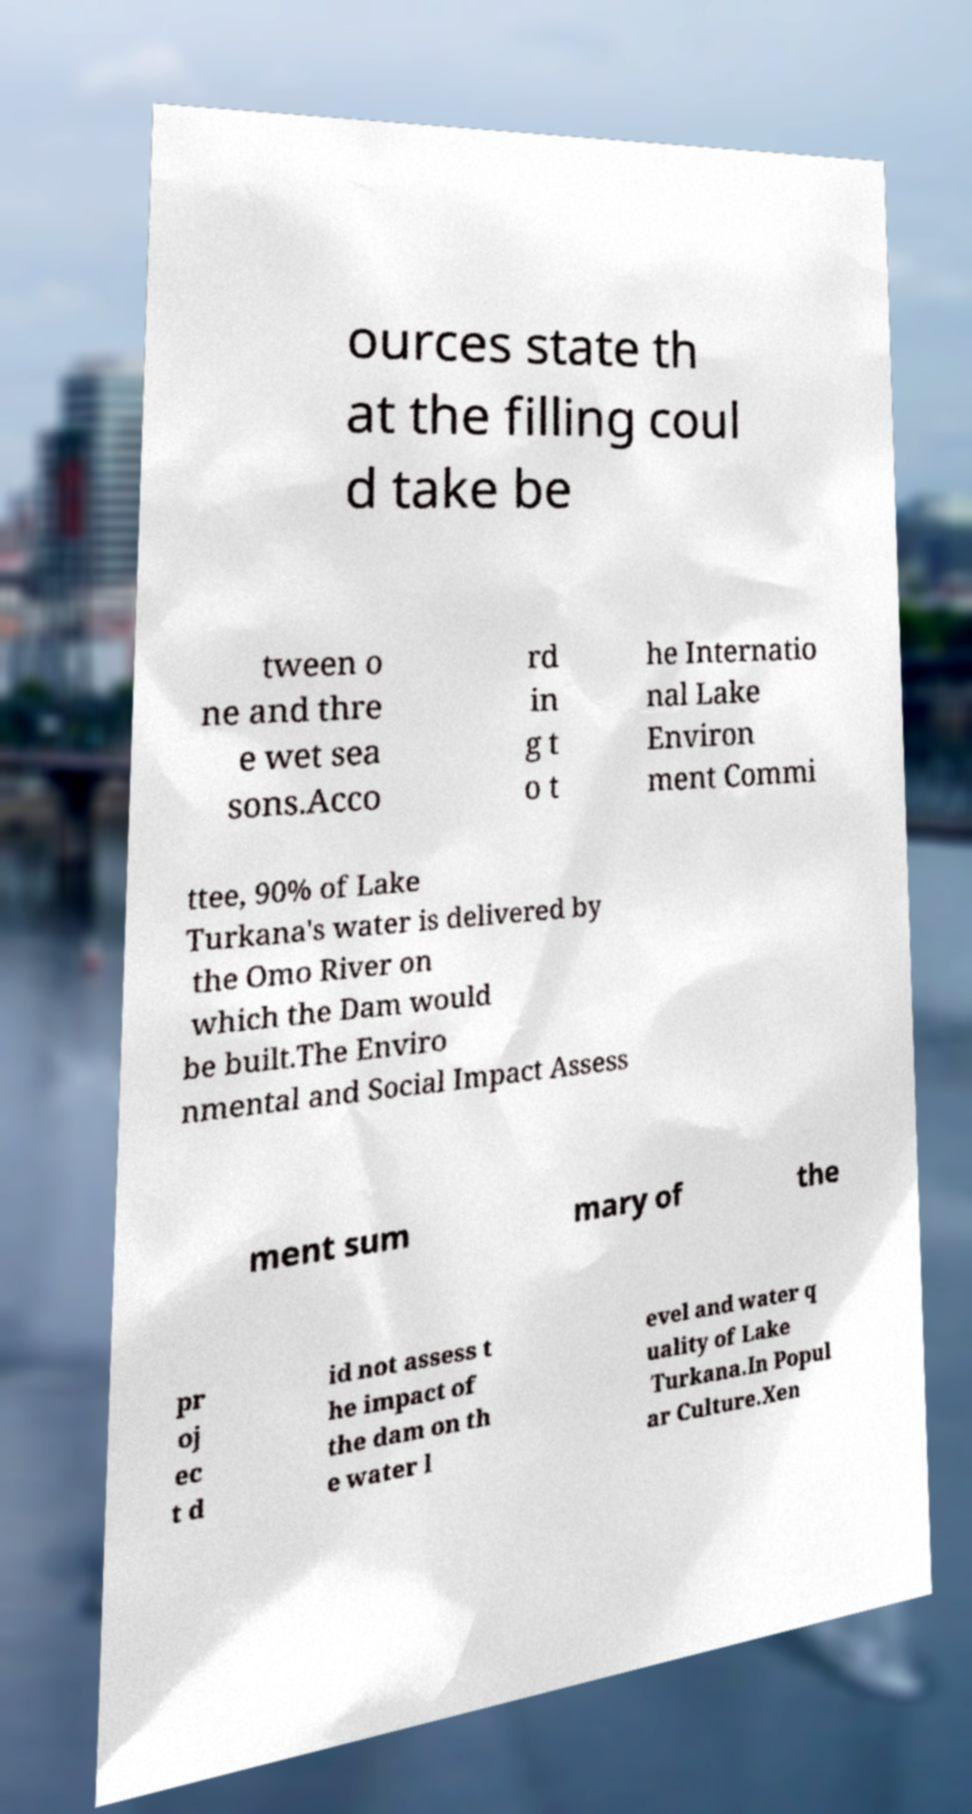There's text embedded in this image that I need extracted. Can you transcribe it verbatim? ources state th at the filling coul d take be tween o ne and thre e wet sea sons.Acco rd in g t o t he Internatio nal Lake Environ ment Commi ttee, 90% of Lake Turkana's water is delivered by the Omo River on which the Dam would be built.The Enviro nmental and Social Impact Assess ment sum mary of the pr oj ec t d id not assess t he impact of the dam on th e water l evel and water q uality of Lake Turkana.In Popul ar Culture.Xen 